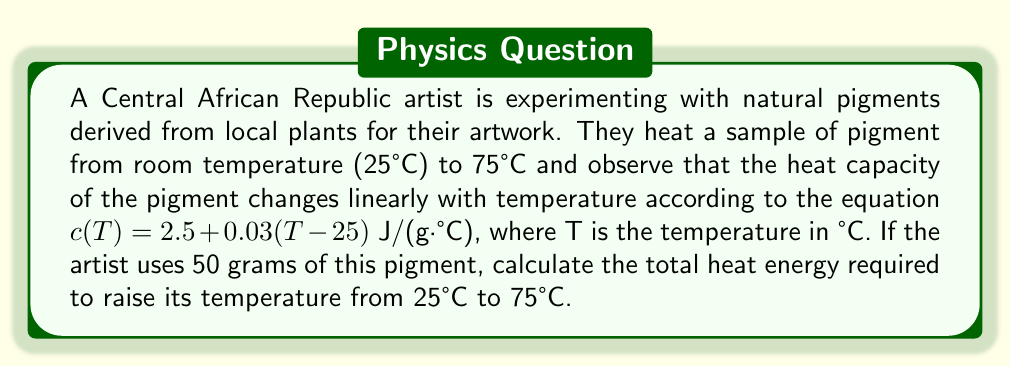Can you answer this question? To solve this problem, we need to use the heat capacity equation and integrate it over the temperature range. Let's break it down step-by-step:

1) The heat capacity is given by $c(T) = 2.5 + 0.03(T-25)$ J/(g·°C)

2) The heat energy $Q$ is given by the integral:

   $$Q = m \int_{T_1}^{T_2} c(T) dT$$

   where $m$ is the mass of the pigment, $T_1$ is the initial temperature, and $T_2$ is the final temperature.

3) Substituting the values:
   
   $$Q = 50 \int_{25}^{75} (2.5 + 0.03(T-25)) dT$$

4) Expanding the integral:

   $$Q = 50 \int_{25}^{75} (2.5 + 0.03T - 0.75) dT$$
   $$Q = 50 \int_{25}^{75} (1.75 + 0.03T) dT$$

5) Integrating:

   $$Q = 50 [1.75T + 0.015T^2]_{25}^{75}$$

6) Evaluating the integral:

   $$Q = 50 [(1.75 \cdot 75 + 0.015 \cdot 75^2) - (1.75 \cdot 25 + 0.015 \cdot 25^2)]$$
   $$Q = 50 [131.25 + 84.375 - 43.75 - 9.375]$$
   $$Q = 50 \cdot 162.5$$
   $$Q = 8125 \text{ J}$$

Therefore, the total heat energy required is 8125 Joules.
Answer: 8125 J 